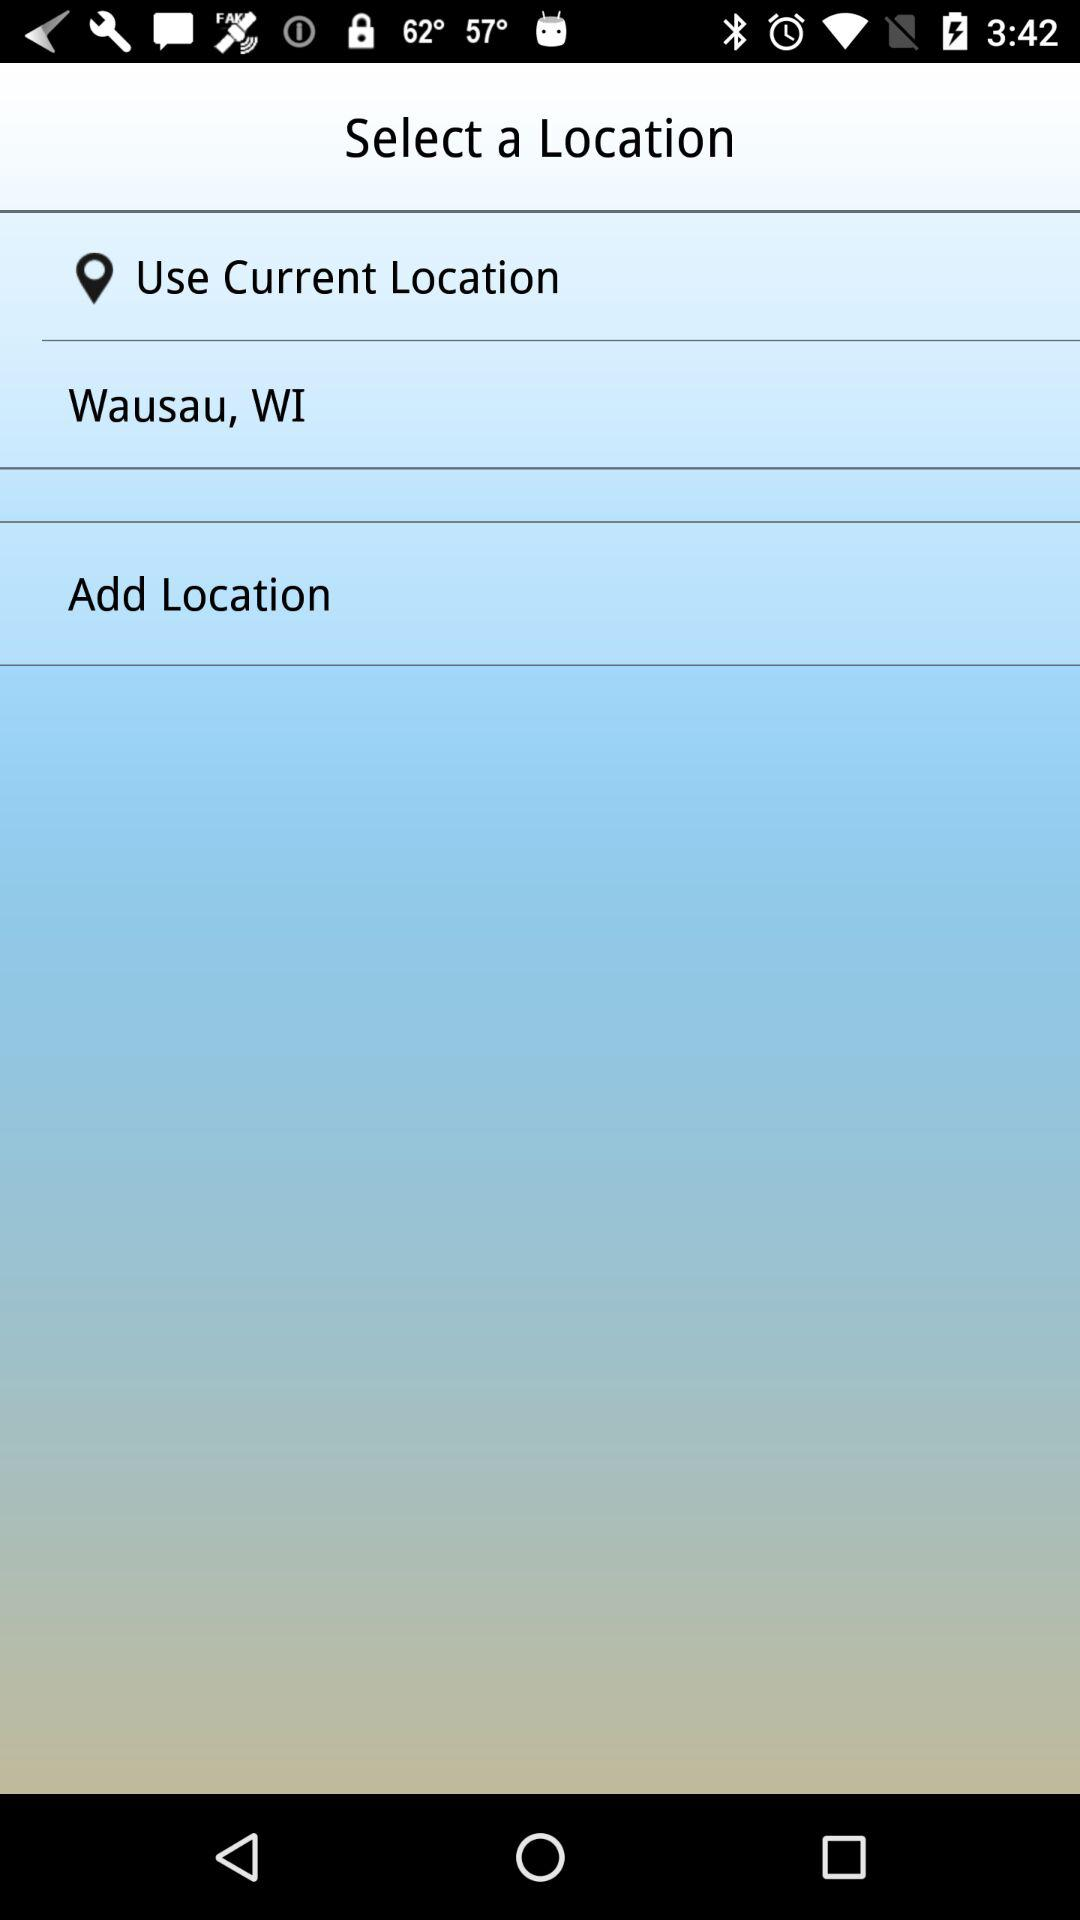How many options are there to select a location?
Answer the question using a single word or phrase. 3 